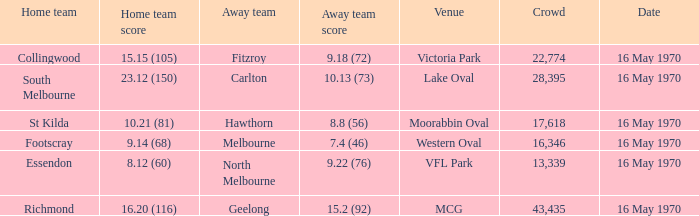What away team scored 9.18 (72)? Fitzroy. 